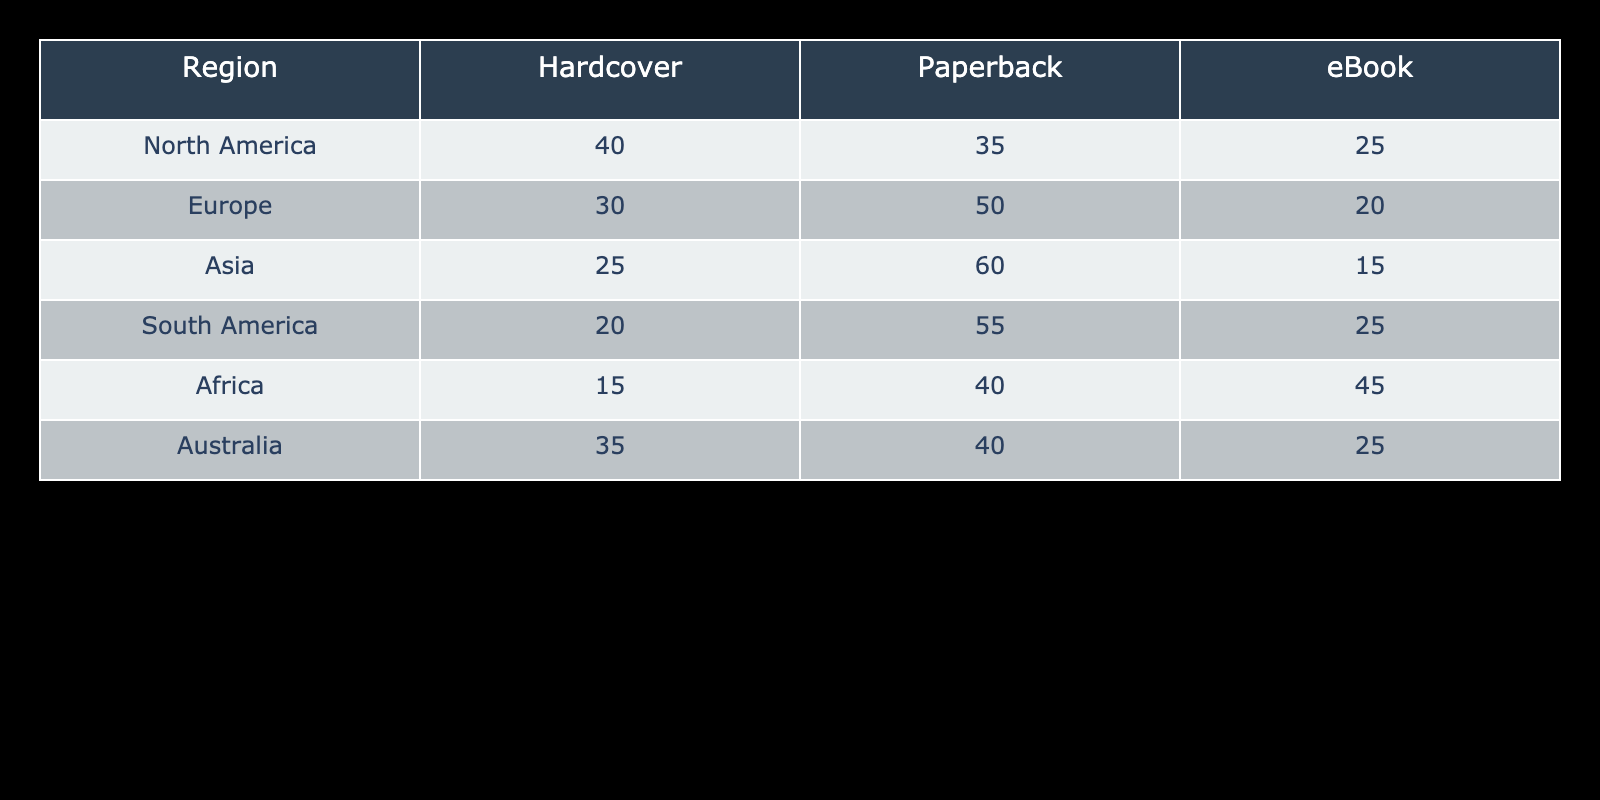What is the total number of eBooks sold in South America? From the table, we see that South America has 25 eBooks sold. We don’t need to do any additional calculations since we are only looking for one specific value.
Answer: 25 Which region sold the highest number of hardcover books? By comparing the numbers for hardcover books across all regions, North America has the highest value at 40. No calculations are needed here; it's a straightforward retrieval.
Answer: 40 What is the average number of paperback books sold across all regions? To find the average, we first sum the paperback sales from all regions: 35 (NA) + 50 (EU) + 60 (AS) + 55 (SA) + 40 (AF) + 40 (AU) = 280. There are six regions, so we calculate the average by dividing the total by 6: 280 / 6 = 46.67.
Answer: 46.67 Did Africa sell more paperback books than North America? The table shows that Africa sold 40 paperback books while North America sold 35. Since 40 is greater than 35, the statement is true.
Answer: Yes How many more paperback books were sold in Europe than in Asia? In Europe, paperback sales are 50, and in Asia, they are 60. To find out how many more were sold in Europe, we subtract Asia's sales from Europe's: 50 - 60 = -10. Since the result is negative, it indicates that Europe sold fewer paperback books than Asia.
Answer: 10 fewer Which region sold the lowest number of hardcover books, and what is that number? By checking the figures, we see that Africa has the lowest hardcover sales at 15. This is a direct comparison between all the values for hardcover books, and no calculations are necessary.
Answer: 15 Is the total number of books sold in North America greater than in Australia? First, we calculate the total for North America: 40 (hardcover) + 35 (paperback) + 25 (eBook) = 100. Then we calculate Australia: 35 (hardcover) + 40 (paperback) + 25 (eBook) = 100. Since both totals are equal (100), the answer is no.
Answer: No What percentage of the total books sold in Africa are eBooks? First, we need the total number of books sold in Africa: 15 (hardcover) + 40 (paperback) + 45 (eBook) = 100. The number of eBooks sold is 45. To find the percentage, we use the formula (eBooks / total) * 100, so (45 / 100) * 100 = 45%.
Answer: 45% Which format is most popular in Asia, and how many were sold? Looking at the data for Asia, the paperback format has the highest number at 60, compared to hardcover (25) and eBook (15). This is a direct retrieval from the table.
Answer: Paperback, 60 